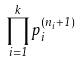Convert formula to latex. <formula><loc_0><loc_0><loc_500><loc_500>\prod _ { i = 1 } ^ { k } p _ { i } ^ { ( n _ { i } + 1 ) }</formula> 